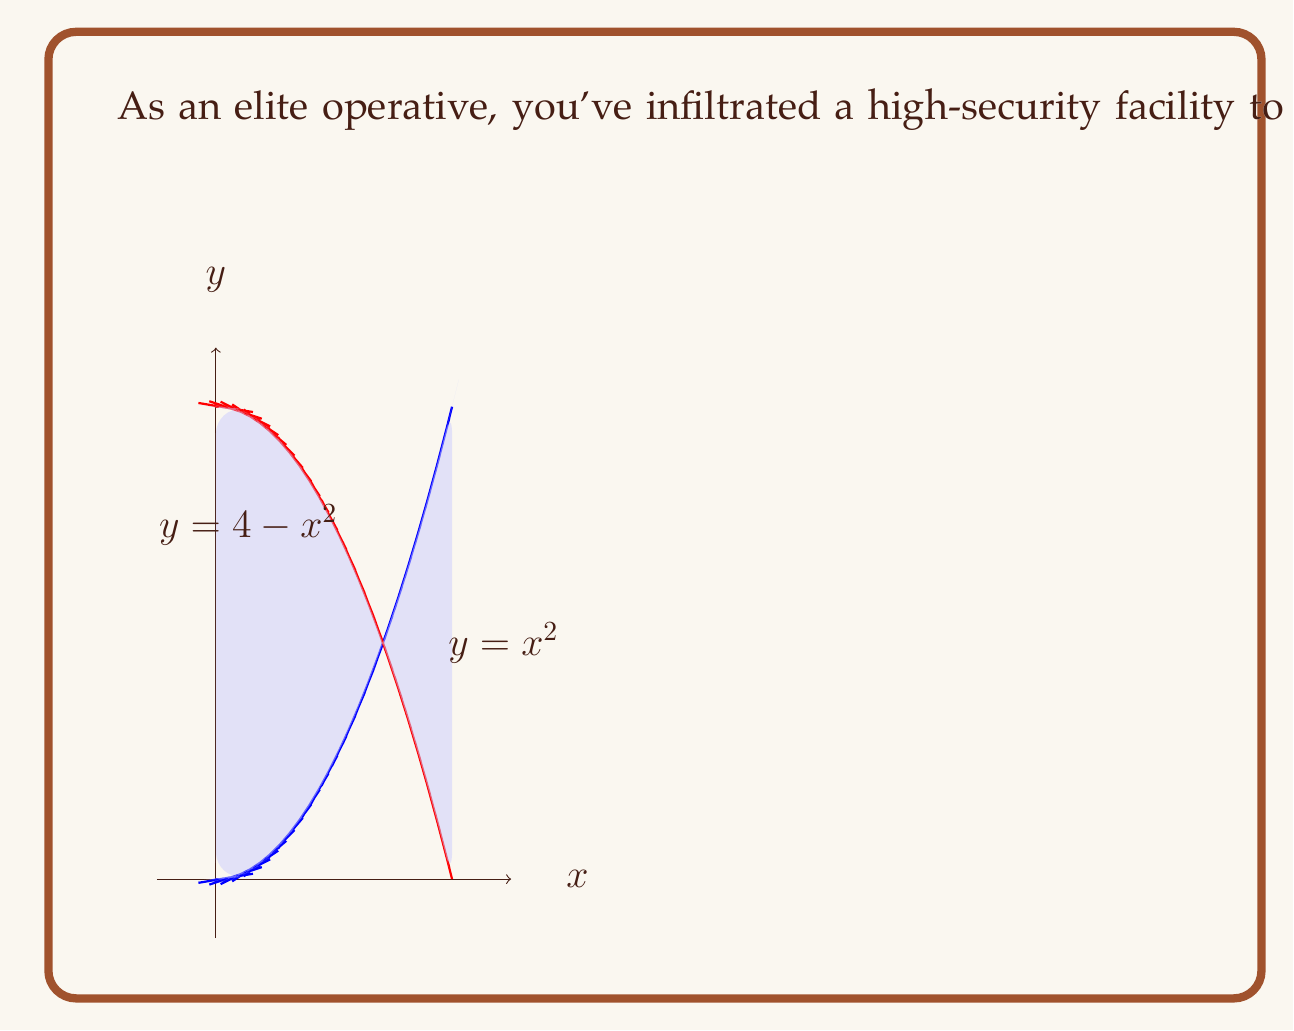Can you solve this math problem? To estimate the area of this irregularly shaped region, we'll use the following steps:

1) Identify the limits of integration:
   The region is bounded by the y-axis (x = 0) and the intersection of $y = x^2$ and $y = 4 - x^2$.
   To find the intersection, solve:
   $$x^2 = 4 - x^2$$
   $$2x^2 = 4$$
   $$x^2 = 2$$
   $$x = \sqrt{2}$$

2) Set up the integral:
   The area is the difference between the upper curve ($y = 4 - x^2$) and the lower curve ($y = x^2$):
   $$A = \int_0^{\sqrt{2}} [(4 - x^2) - x^2] dx$$

3) Simplify the integrand:
   $$A = \int_0^{\sqrt{2}} [4 - 2x^2] dx$$

4) Integrate:
   $$A = [4x - \frac{2x^3}{3}]_0^{\sqrt{2}}$$

5) Evaluate the definite integral:
   $$A = (4\sqrt{2} - \frac{2(\sqrt{2})^3}{3}) - (0 - 0)$$
   $$A = 4\sqrt{2} - \frac{4\sqrt{2}}{3}$$
   $$A = \frac{12\sqrt{2}}{3} - \frac{4\sqrt{2}}{3}$$
   $$A = \frac{8\sqrt{2}}{3}$$

6) Simplify:
   $$A = \frac{8\sqrt{2}}{3} \approx 3.77 \text{ square units}$$
Answer: $\frac{8\sqrt{2}}{3}$ square units 